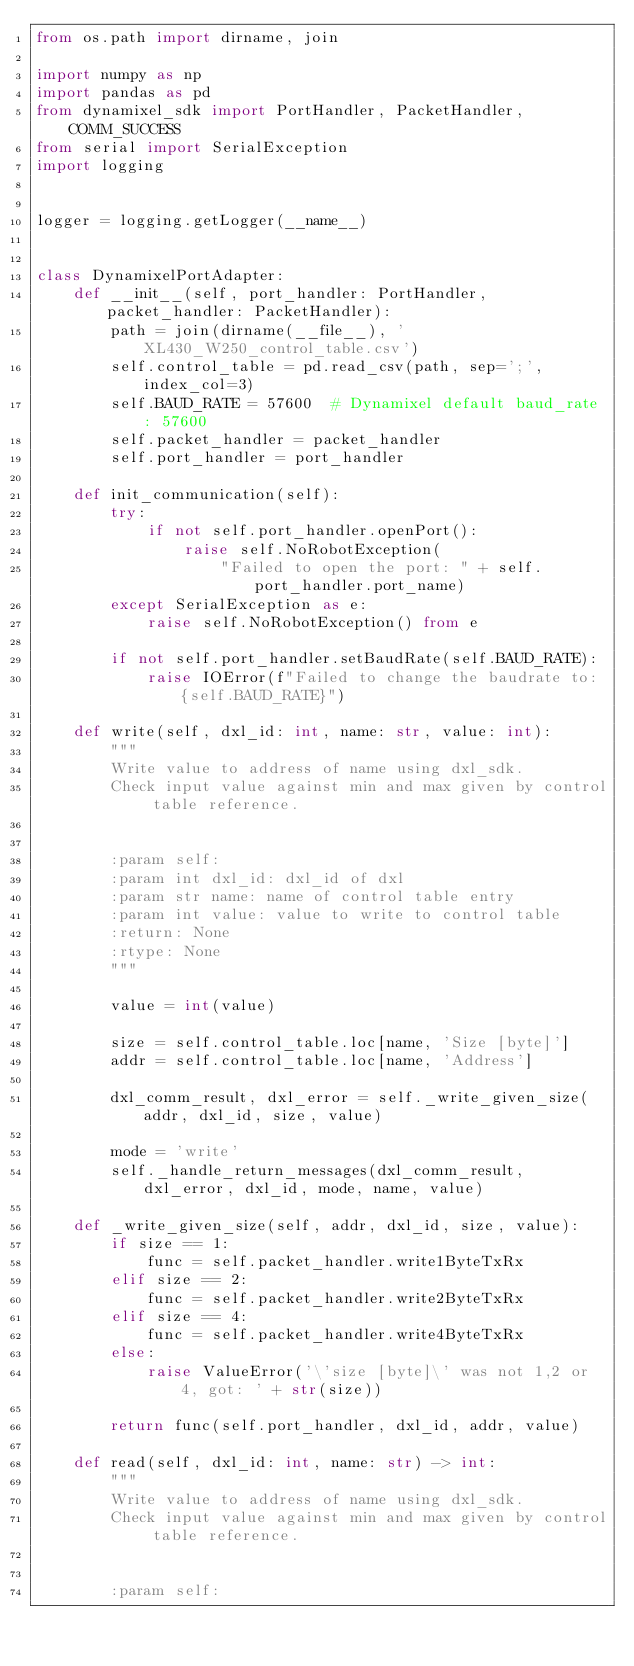<code> <loc_0><loc_0><loc_500><loc_500><_Python_>from os.path import dirname, join

import numpy as np
import pandas as pd
from dynamixel_sdk import PortHandler, PacketHandler, COMM_SUCCESS
from serial import SerialException
import logging


logger = logging.getLogger(__name__)


class DynamixelPortAdapter:
    def __init__(self, port_handler: PortHandler, packet_handler: PacketHandler):
        path = join(dirname(__file__), 'XL430_W250_control_table.csv')
        self.control_table = pd.read_csv(path, sep=';', index_col=3)
        self.BAUD_RATE = 57600  # Dynamixel default baud_rate : 57600
        self.packet_handler = packet_handler
        self.port_handler = port_handler

    def init_communication(self):
        try:
            if not self.port_handler.openPort():
                raise self.NoRobotException(
                    "Failed to open the port: " + self.port_handler.port_name)
        except SerialException as e:
            raise self.NoRobotException() from e

        if not self.port_handler.setBaudRate(self.BAUD_RATE):
            raise IOError(f"Failed to change the baudrate to: {self.BAUD_RATE}")

    def write(self, dxl_id: int, name: str, value: int):
        """
        Write value to address of name using dxl_sdk.
        Check input value against min and max given by control table reference.


        :param self:
        :param int dxl_id: dxl_id of dxl
        :param str name: name of control table entry
        :param int value: value to write to control table
        :return: None
        :rtype: None
        """

        value = int(value)

        size = self.control_table.loc[name, 'Size [byte]']
        addr = self.control_table.loc[name, 'Address']

        dxl_comm_result, dxl_error = self._write_given_size(addr, dxl_id, size, value)

        mode = 'write'
        self._handle_return_messages(dxl_comm_result, dxl_error, dxl_id, mode, name, value)

    def _write_given_size(self, addr, dxl_id, size, value):
        if size == 1:
            func = self.packet_handler.write1ByteTxRx
        elif size == 2:
            func = self.packet_handler.write2ByteTxRx
        elif size == 4:
            func = self.packet_handler.write4ByteTxRx
        else:
            raise ValueError('\'size [byte]\' was not 1,2 or 4, got: ' + str(size))

        return func(self.port_handler, dxl_id, addr, value)

    def read(self, dxl_id: int, name: str) -> int:
        """
        Write value to address of name using dxl_sdk.
        Check input value against min and max given by control table reference.


        :param self:</code> 